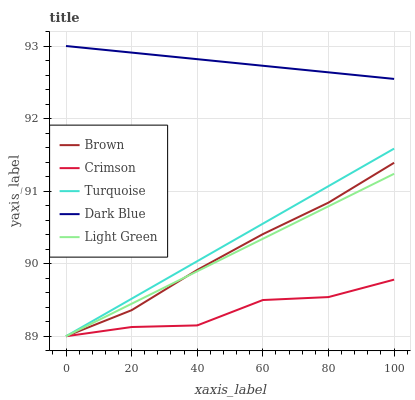Does Crimson have the minimum area under the curve?
Answer yes or no. Yes. Does Dark Blue have the maximum area under the curve?
Answer yes or no. Yes. Does Brown have the minimum area under the curve?
Answer yes or no. No. Does Brown have the maximum area under the curve?
Answer yes or no. No. Is Turquoise the smoothest?
Answer yes or no. Yes. Is Crimson the roughest?
Answer yes or no. Yes. Is Brown the smoothest?
Answer yes or no. No. Is Brown the roughest?
Answer yes or no. No. Does Crimson have the lowest value?
Answer yes or no. Yes. Does Dark Blue have the lowest value?
Answer yes or no. No. Does Dark Blue have the highest value?
Answer yes or no. Yes. Does Brown have the highest value?
Answer yes or no. No. Is Brown less than Dark Blue?
Answer yes or no. Yes. Is Dark Blue greater than Crimson?
Answer yes or no. Yes. Does Crimson intersect Light Green?
Answer yes or no. Yes. Is Crimson less than Light Green?
Answer yes or no. No. Is Crimson greater than Light Green?
Answer yes or no. No. Does Brown intersect Dark Blue?
Answer yes or no. No. 